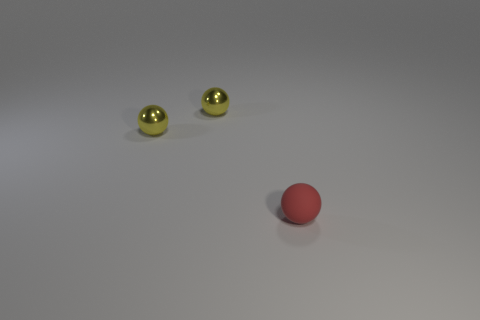What color is the matte thing?
Offer a very short reply. Red. Is the number of tiny red rubber things that are in front of the small matte object greater than the number of small red matte spheres?
Provide a short and direct response. No. There is a tiny red object; how many tiny yellow spheres are in front of it?
Give a very brief answer. 0. Is the number of tiny shiny objects that are to the right of the red object the same as the number of matte spheres?
Make the answer very short. No. What number of other things are the same material as the red object?
Give a very brief answer. 0. How many things are either objects that are left of the tiny matte sphere or objects to the left of the small red thing?
Provide a short and direct response. 2. Is there any other thing that is the same shape as the tiny matte thing?
Ensure brevity in your answer.  Yes. What number of metal objects are either red balls or large blue cylinders?
Offer a very short reply. 0. Is there any other thing that has the same size as the rubber object?
Your answer should be very brief. Yes. There is a small matte thing; what shape is it?
Offer a terse response. Sphere. 